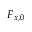<formula> <loc_0><loc_0><loc_500><loc_500>F _ { x , 0 }</formula> 